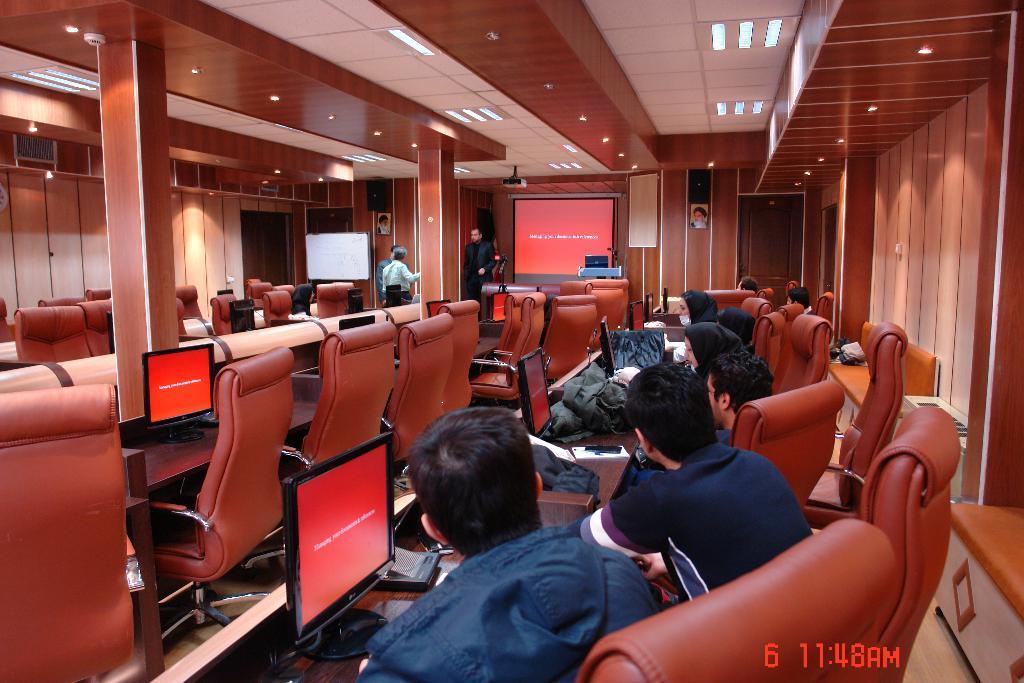In one or two sentences, can you explain what this image depicts? In this picture I can see a group of people are sitting on the chairs and looking at the desktops. There is the time at the bottom, in the middle few persons are standing. At the top there are ceiling lights. 